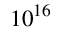<formula> <loc_0><loc_0><loc_500><loc_500>1 0 ^ { 1 6 }</formula> 